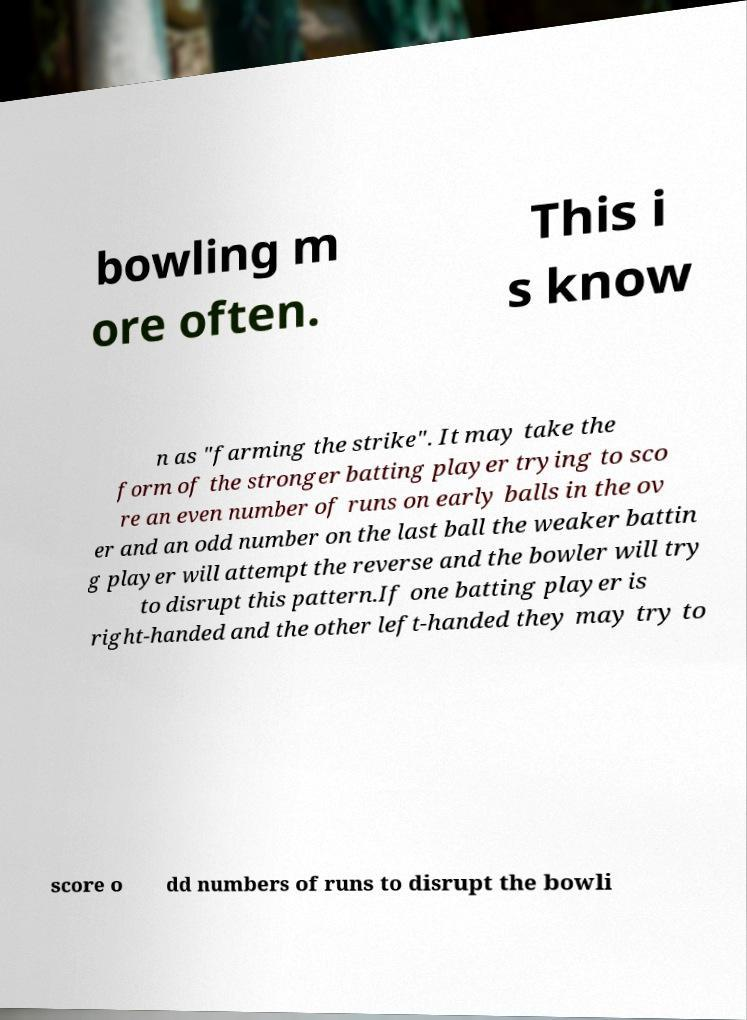For documentation purposes, I need the text within this image transcribed. Could you provide that? bowling m ore often. This i s know n as "farming the strike". It may take the form of the stronger batting player trying to sco re an even number of runs on early balls in the ov er and an odd number on the last ball the weaker battin g player will attempt the reverse and the bowler will try to disrupt this pattern.If one batting player is right-handed and the other left-handed they may try to score o dd numbers of runs to disrupt the bowli 